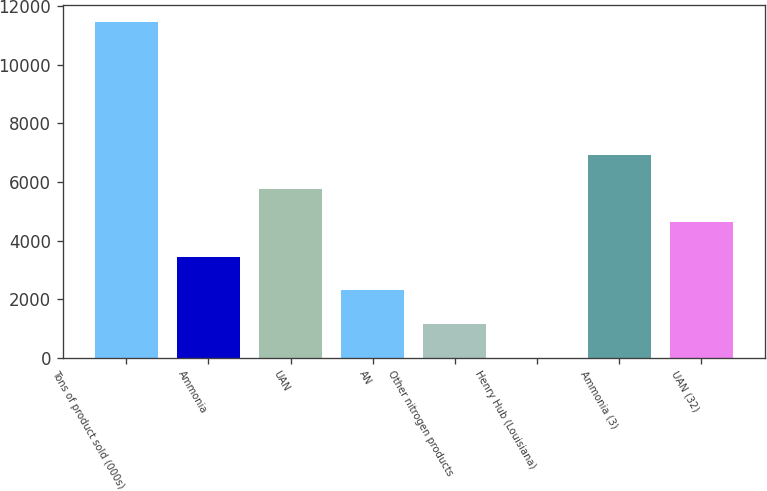Convert chart to OTSL. <chart><loc_0><loc_0><loc_500><loc_500><bar_chart><fcel>Tons of product sold (000s)<fcel>Ammonia<fcel>UAN<fcel>AN<fcel>Other nitrogen products<fcel>Henry Hub (Louisiana)<fcel>Ammonia (3)<fcel>UAN (32)<nl><fcel>11461<fcel>3441.35<fcel>5771.66<fcel>2295.69<fcel>1150.03<fcel>4.37<fcel>6917.32<fcel>4626<nl></chart> 